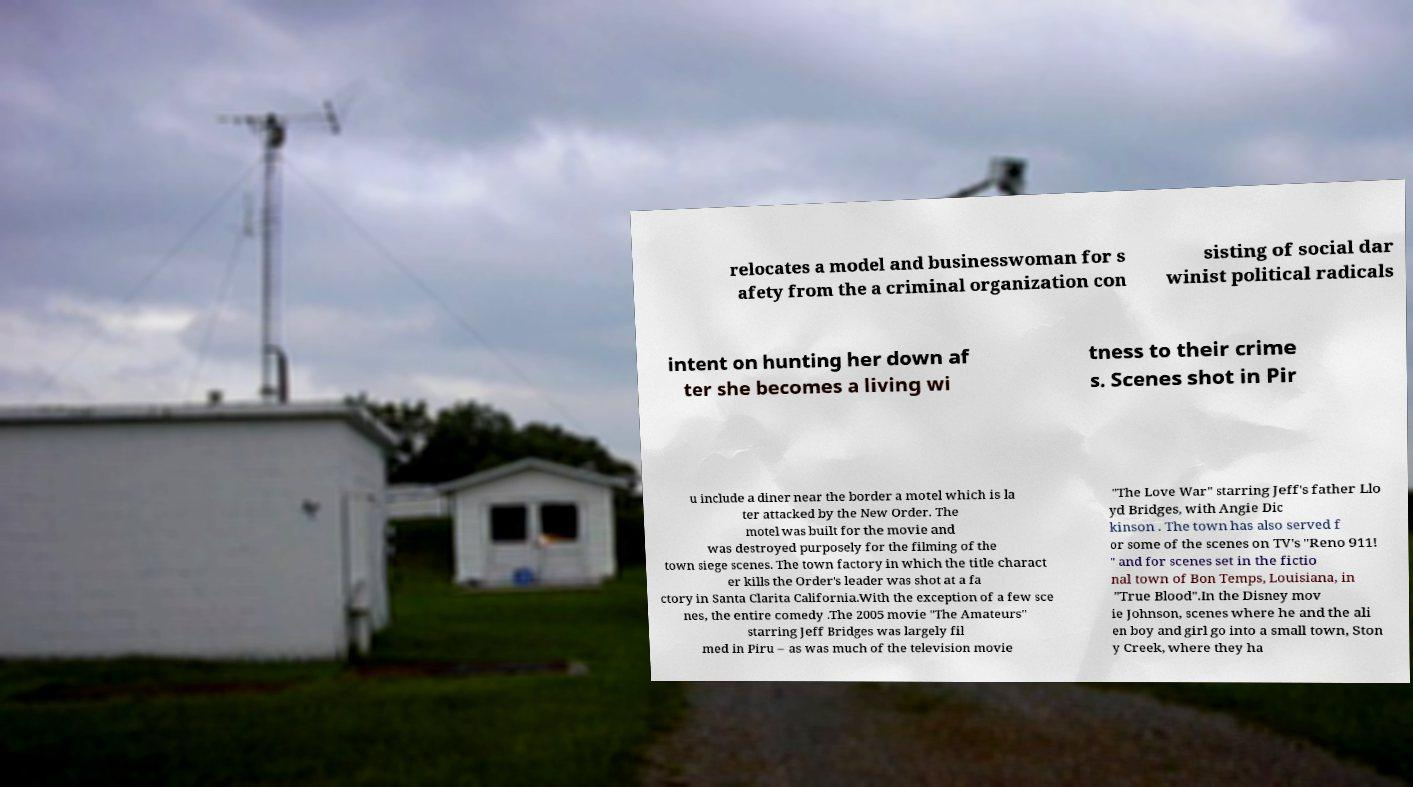Could you extract and type out the text from this image? relocates a model and businesswoman for s afety from the a criminal organization con sisting of social dar winist political radicals intent on hunting her down af ter she becomes a living wi tness to their crime s. Scenes shot in Pir u include a diner near the border a motel which is la ter attacked by the New Order. The motel was built for the movie and was destroyed purposely for the filming of the town siege scenes. The town factory in which the title charact er kills the Order's leader was shot at a fa ctory in Santa Clarita California.With the exception of a few sce nes, the entire comedy .The 2005 movie "The Amateurs" starring Jeff Bridges was largely fil med in Piru – as was much of the television movie "The Love War" starring Jeff's father Llo yd Bridges, with Angie Dic kinson . The town has also served f or some of the scenes on TV's "Reno 911! " and for scenes set in the fictio nal town of Bon Temps, Louisiana, in "True Blood".In the Disney mov ie Johnson, scenes where he and the ali en boy and girl go into a small town, Ston y Creek, where they ha 